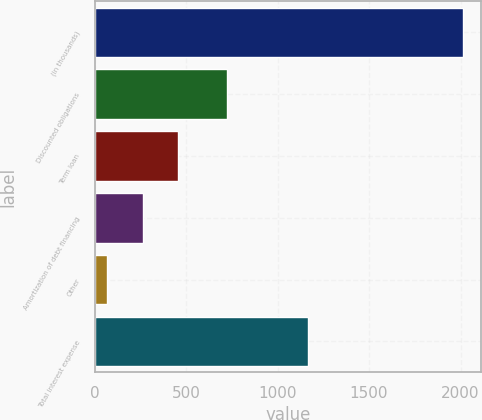Convert chart to OTSL. <chart><loc_0><loc_0><loc_500><loc_500><bar_chart><fcel>(in thousands)<fcel>Discounted obligations<fcel>Term loan<fcel>Amortization of debt financing<fcel>Other<fcel>Total interest expense<nl><fcel>2013<fcel>722<fcel>457<fcel>262.5<fcel>68<fcel>1169<nl></chart> 